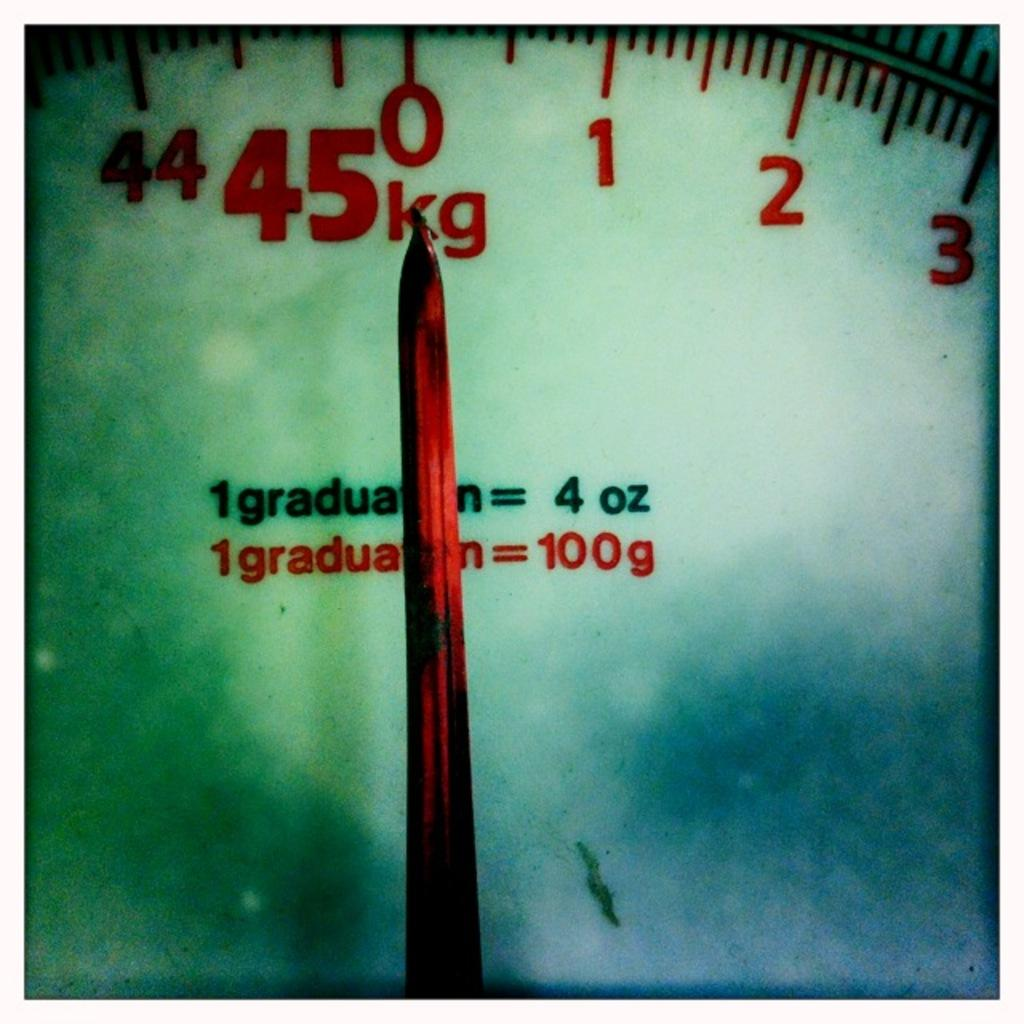Provide a one-sentence caption for the provided image. A weight scale that is set and zero and measures in kilograms. 